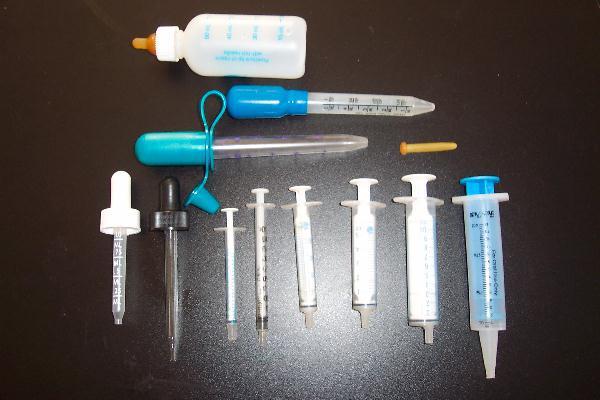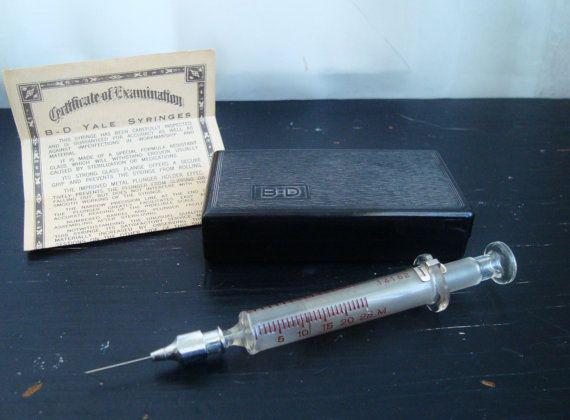The first image is the image on the left, the second image is the image on the right. Given the left and right images, does the statement "One syringe is in front of a rectangular item in one image." hold true? Answer yes or no. Yes. The first image is the image on the left, the second image is the image on the right. For the images shown, is this caption "The right image shows a pair of syringes that have been used to construct some sort of mechanism with a wheel on it." true? Answer yes or no. No. 